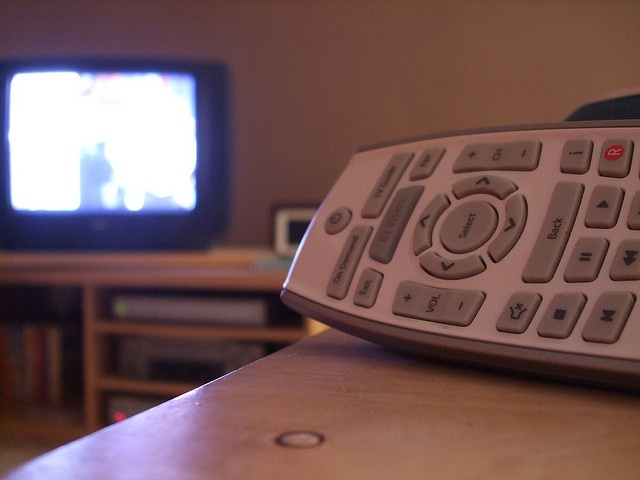Describe the objects in this image and their specific colors. I can see remote in black, gray, brown, and maroon tones and tv in black, white, navy, and lightblue tones in this image. 